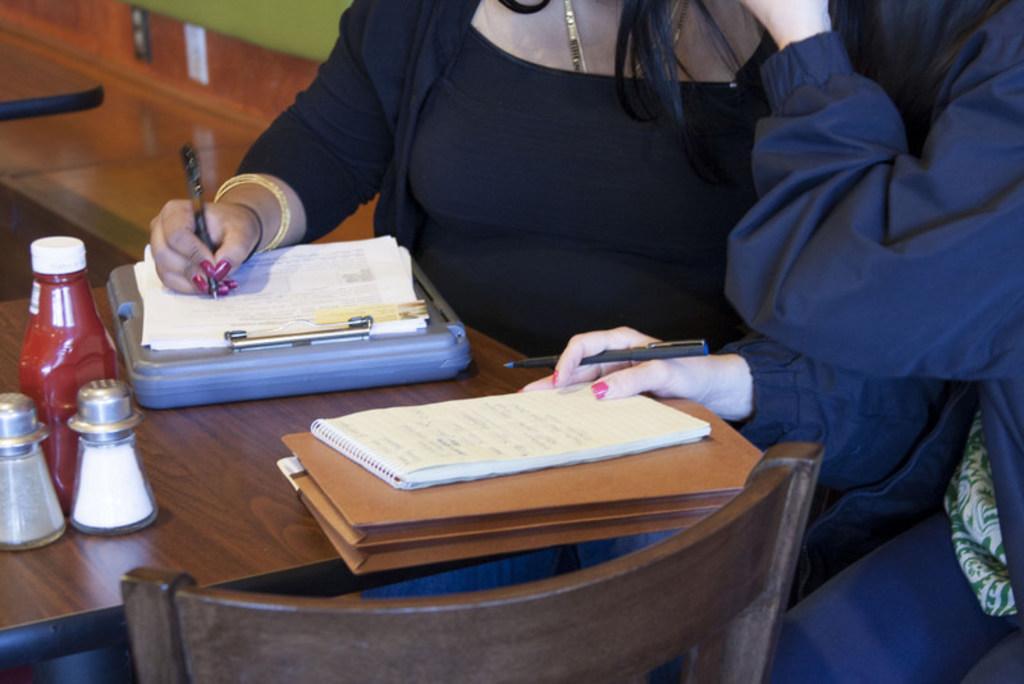Please provide a concise description of this image. In this image there are two women sitting inside a table. Both the women are holding are holding pens. A woman in the black dress, she is writing on the paper. On the table there are three bottles, files and a pad. In the bottom there is a chair. 